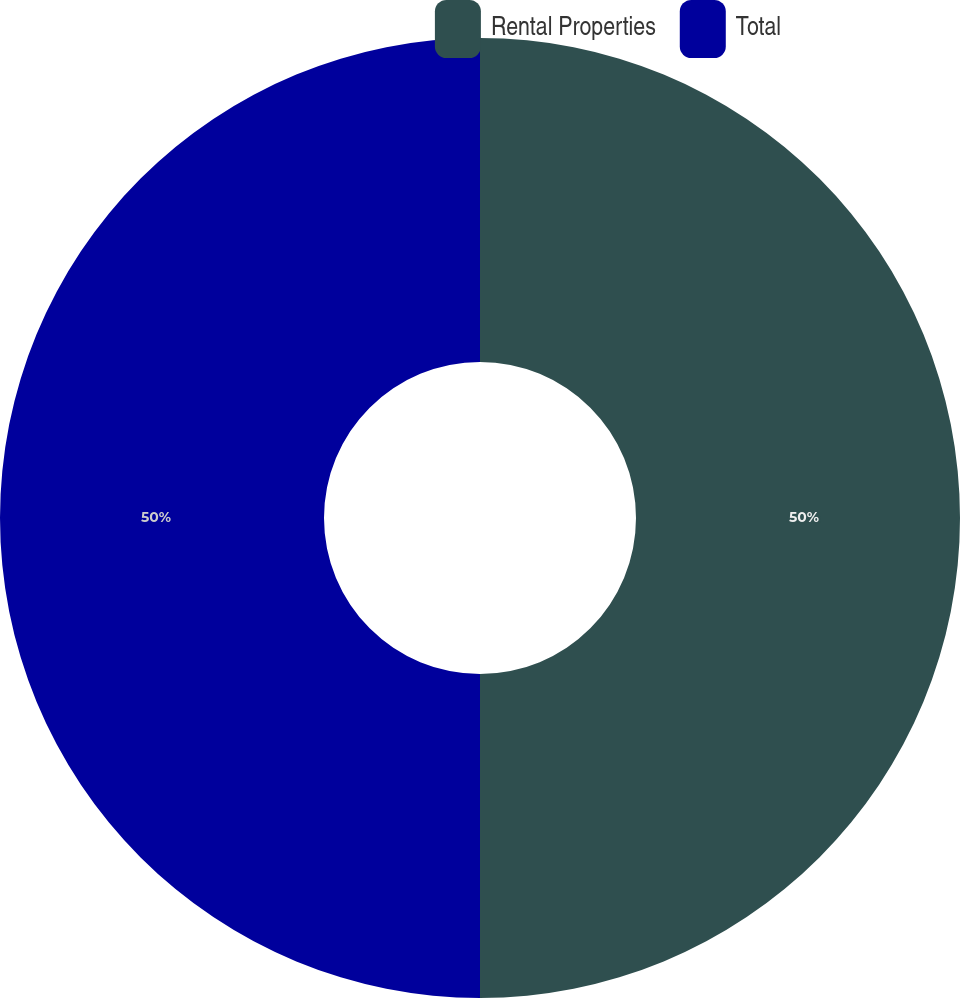<chart> <loc_0><loc_0><loc_500><loc_500><pie_chart><fcel>Rental Properties<fcel>Total<nl><fcel>50.0%<fcel>50.0%<nl></chart> 